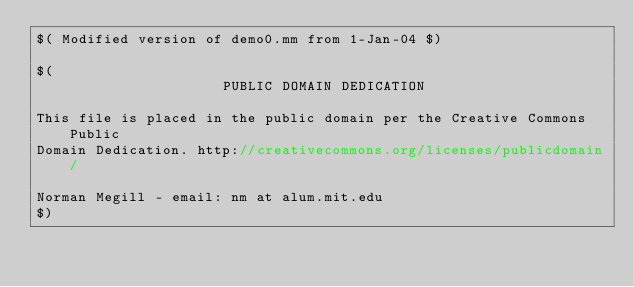<code> <loc_0><loc_0><loc_500><loc_500><_ObjectiveC_>$( Modified version of demo0.mm from 1-Jan-04 $)

$(
                      PUBLIC DOMAIN DEDICATION

This file is placed in the public domain per the Creative Commons Public
Domain Dedication. http://creativecommons.org/licenses/publicdomain/

Norman Megill - email: nm at alum.mit.edu
$)
</code> 